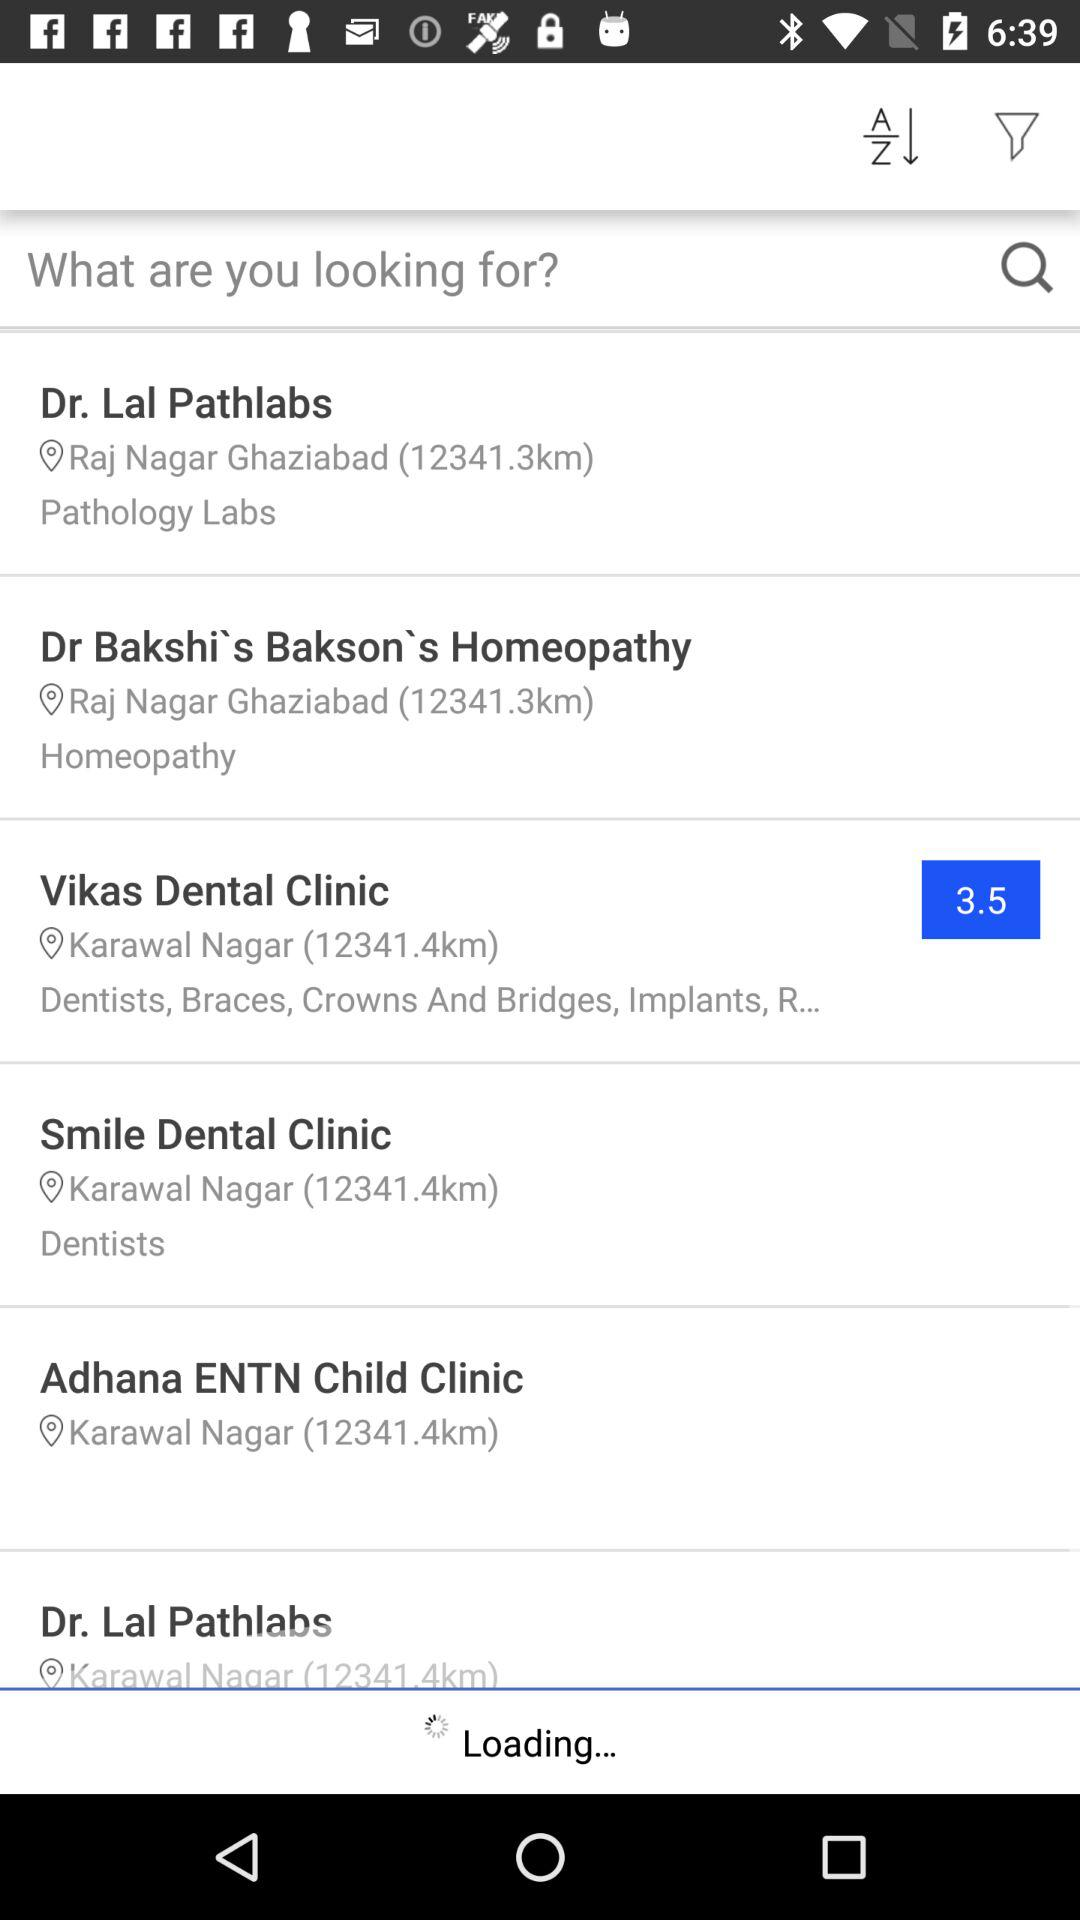For which clinic is homeopathy mentioned?
Answer the question using a single word or phrase. Homeopathy is mentioned for "Dr Bakshi's Bakson's Homeopathy", 